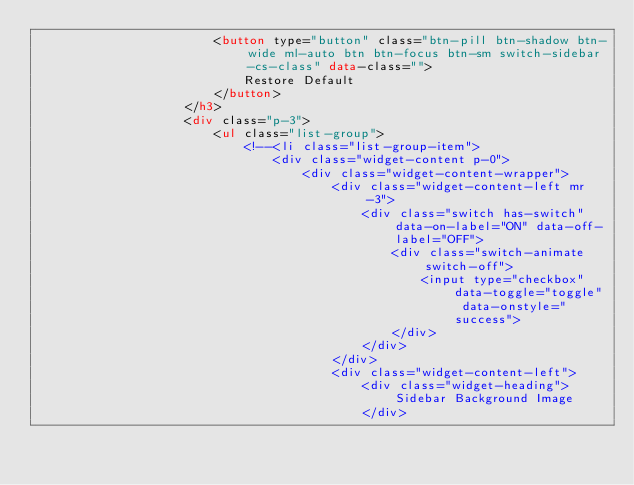<code> <loc_0><loc_0><loc_500><loc_500><_HTML_>                        <button type="button" class="btn-pill btn-shadow btn-wide ml-auto btn btn-focus btn-sm switch-sidebar-cs-class" data-class="">
                            Restore Default
                        </button>
                    </h3>
                    <div class="p-3">
                        <ul class="list-group">
                            <!--<li class="list-group-item">
                                <div class="widget-content p-0">
                                    <div class="widget-content-wrapper">
                                        <div class="widget-content-left mr-3">
                                            <div class="switch has-switch" data-on-label="ON" data-off-label="OFF">
                                                <div class="switch-animate switch-off">
                                                    <input type="checkbox" data-toggle="toggle" data-onstyle="success">
                                                </div>
                                            </div>
                                        </div>
                                        <div class="widget-content-left">
                                            <div class="widget-heading">Sidebar Background Image
                                            </div></code> 